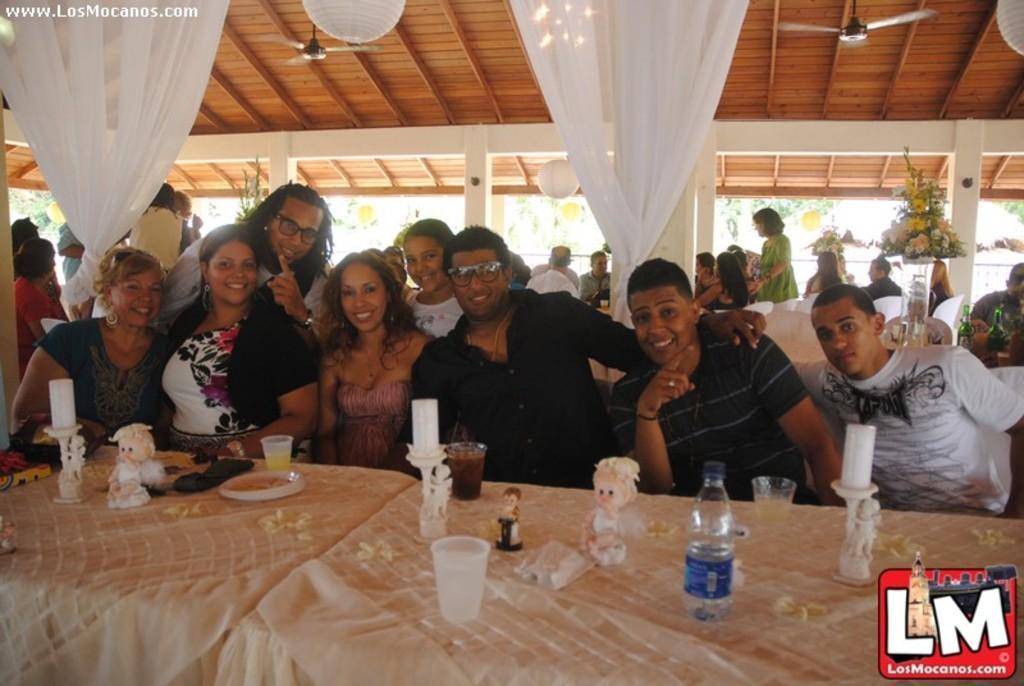Could you give a brief overview of what you see in this image? In this image we can see persons who are sitting and standing on the floor and tables are placed in front of them. On the tables we can see dolls, candles, candle holders, disposable tumblers and disposal bottles. In the background we can see curtains, ceiling fans, lanterns, bouquets, shed and trees. 